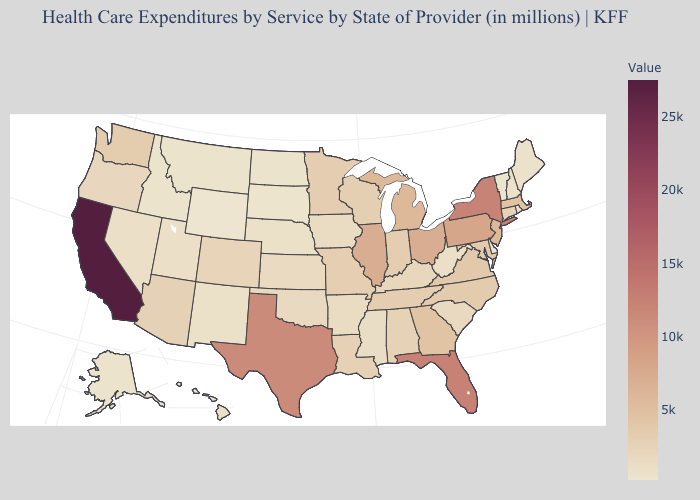Among the states that border Vermont , does New Hampshire have the lowest value?
Quick response, please. Yes. Which states have the lowest value in the USA?
Give a very brief answer. Wyoming. Among the states that border Oklahoma , which have the highest value?
Answer briefly. Texas. Among the states that border Utah , which have the lowest value?
Write a very short answer. Wyoming. Does California have the highest value in the USA?
Concise answer only. Yes. 